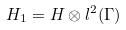Convert formula to latex. <formula><loc_0><loc_0><loc_500><loc_500>H _ { 1 } = H \otimes l ^ { 2 } ( \Gamma )</formula> 